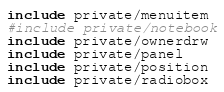<code> <loc_0><loc_0><loc_500><loc_500><_Nim_>include private/menuitem
#include private/notebook
include private/ownerdrw
include private/panel
include private/position
include private/radiobox</code> 